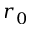Convert formula to latex. <formula><loc_0><loc_0><loc_500><loc_500>r _ { 0 }</formula> 